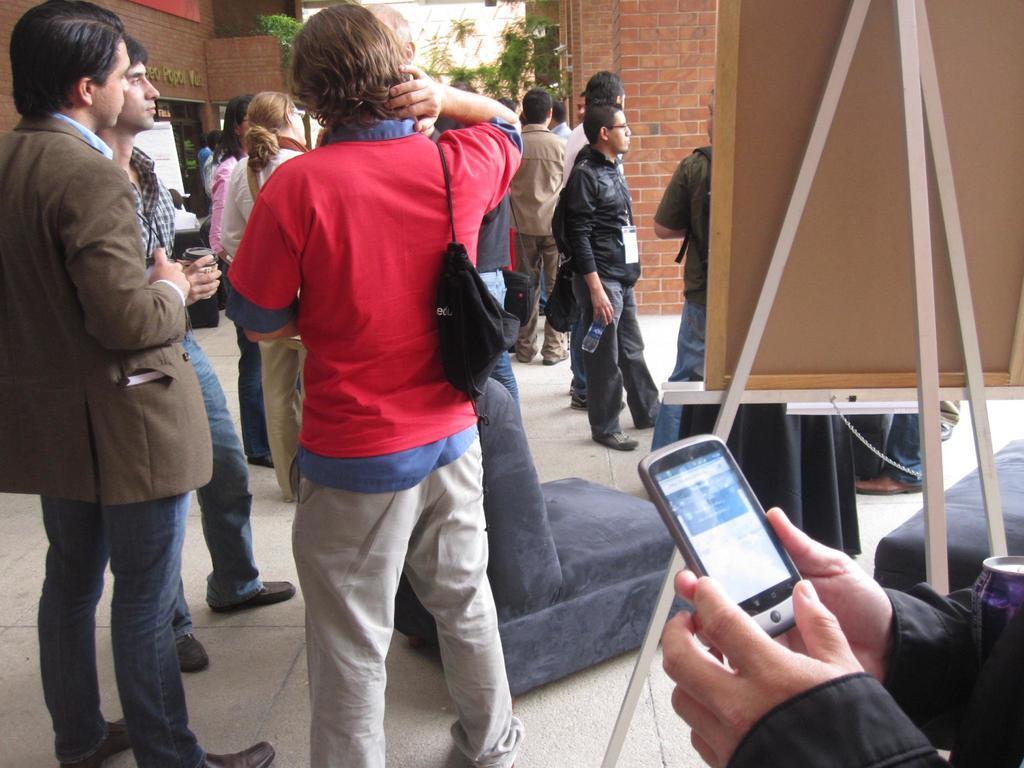Describe this image in one or two sentences. In the image we can see there are lot of people who are standing and a person is holding mobile phone in his hand and there is notice board which is kept on stand and the wall is made up of red bricks. 